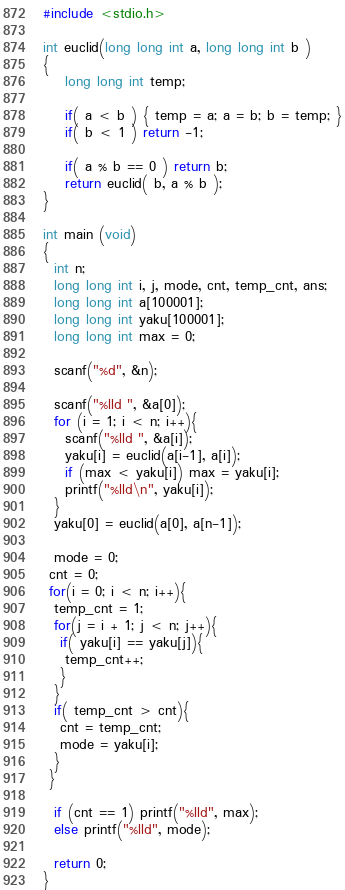Convert code to text. <code><loc_0><loc_0><loc_500><loc_500><_C_>#include <stdio.h>

int euclid(long long int a, long long int b )
{
    long long int temp;

    if( a < b ) { temp = a; a = b; b = temp; }
    if( b < 1 ) return -1;

    if( a % b == 0 ) return b;
    return euclid( b, a % b );
}

int main (void)
{
  int n;
  long long int i, j, mode, cnt, temp_cnt, ans;
  long long int a[100001];
  long long int yaku[100001];
  long long int max = 0;
  
  scanf("%d", &n);
  
  scanf("%lld ", &a[0]);
  for (i = 1; i < n; i++){
    scanf("%lld ", &a[i]);
    yaku[i] = euclid(a[i-1], a[i]);
    if (max < yaku[i]) max = yaku[i];
    printf("%lld\n", yaku[i]);
  }
  yaku[0] = euclid(a[0], a[n-1]);
  
  mode = 0;
 cnt = 0;
 for(i = 0; i < n; i++){
  temp_cnt = 1;
  for(j = i + 1; j < n; j++){
   if( yaku[i] == yaku[j]){
    temp_cnt++;
   }
  }
  if( temp_cnt > cnt){
   cnt = temp_cnt;
   mode = yaku[i];
  }
 }
    
  if (cnt == 1) printf("%lld", max);
  else printf("%lld", mode);
  
  return 0;
}</code> 